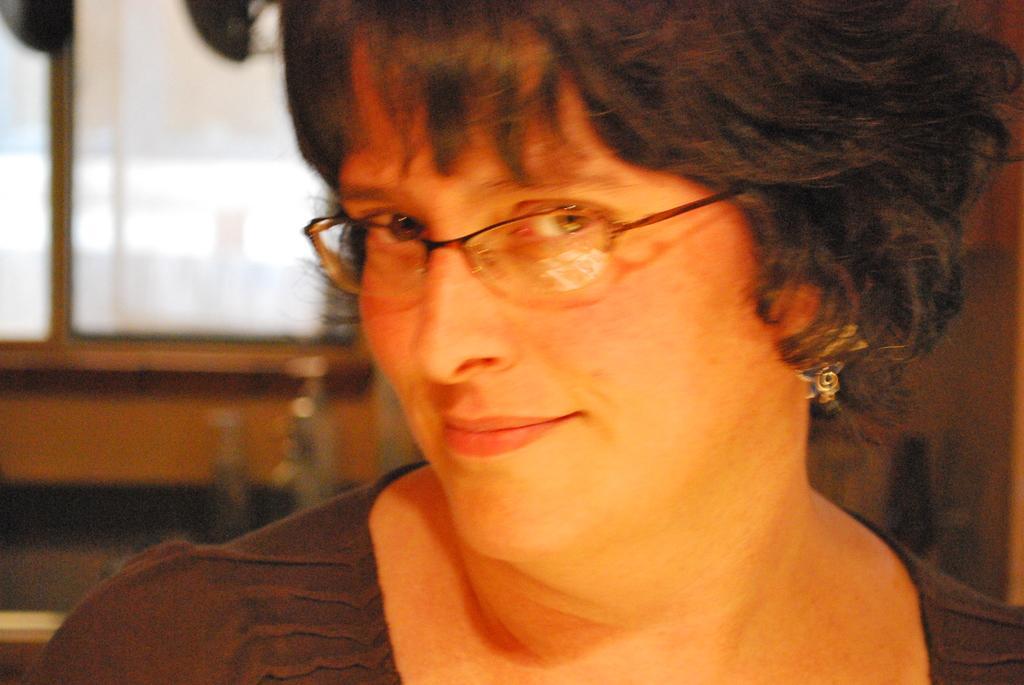In one or two sentences, can you explain what this image depicts? In this picture there is a woman wearing spectacles and an earring to her ear and there are some other objects in the background. 